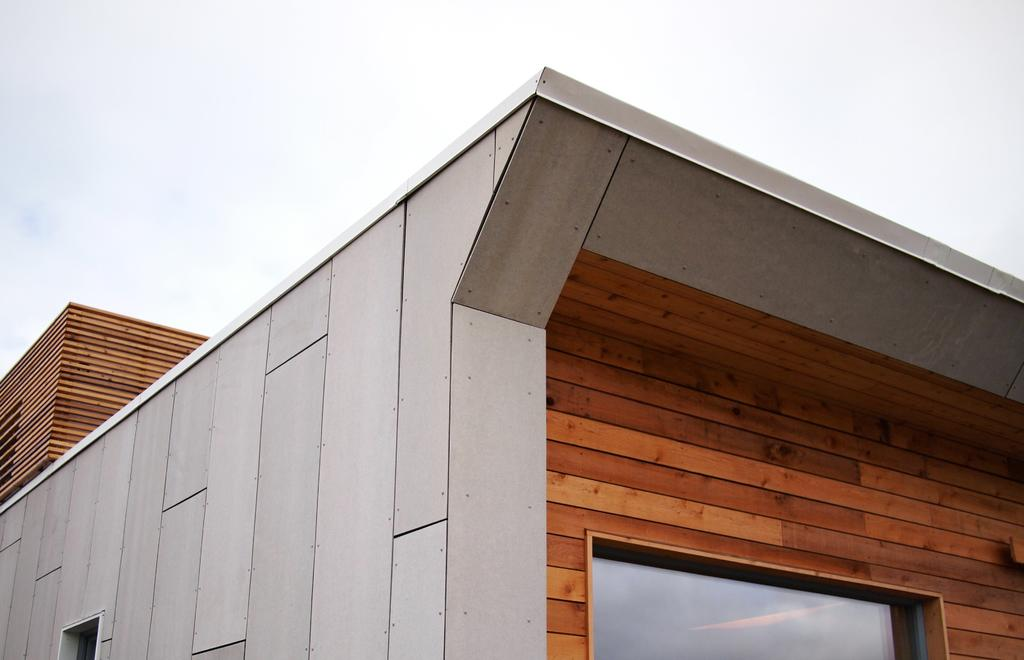What is the main structure in the image? There is a building in the image. What feature can be seen on the building's wall? The building has a window on the wall. What can be seen in the background of the image? The sky is visible in the background of the image. What type of wound can be seen on the doctor's brain in the image? There is no doctor or brain present in the image; it only features a building with a window and the sky in the background. 